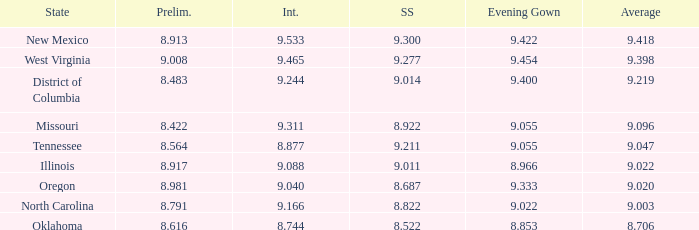Name the swuinsuit for oregon 8.687. 